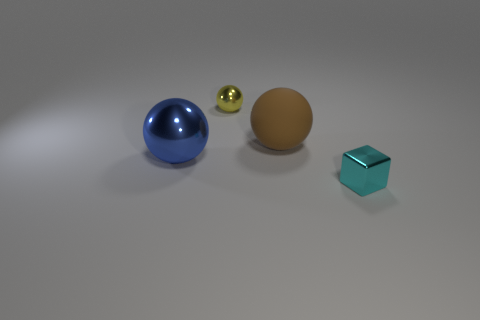Does the small thing that is in front of the brown matte sphere have the same material as the tiny thing that is to the left of the tiny cyan block?
Your response must be concise. Yes. How many objects are large metallic things or spheres in front of the large brown ball?
Your answer should be very brief. 1. What number of big brown rubber objects have the same shape as the blue thing?
Make the answer very short. 1. There is a object that is the same size as the cyan cube; what material is it?
Offer a terse response. Metal. There is a shiny ball in front of the big sphere right of the tiny object left of the big rubber sphere; how big is it?
Ensure brevity in your answer.  Large. What number of brown things are either tiny spheres or large spheres?
Ensure brevity in your answer.  1. How many other rubber things are the same size as the brown rubber thing?
Offer a very short reply. 0. Does the small thing left of the small cyan shiny object have the same material as the tiny cyan cube?
Your answer should be compact. Yes. Is there a tiny yellow metal object that is to the right of the tiny metallic thing that is in front of the small yellow ball?
Keep it short and to the point. No. There is another big object that is the same shape as the blue shiny thing; what is its material?
Your response must be concise. Rubber. 